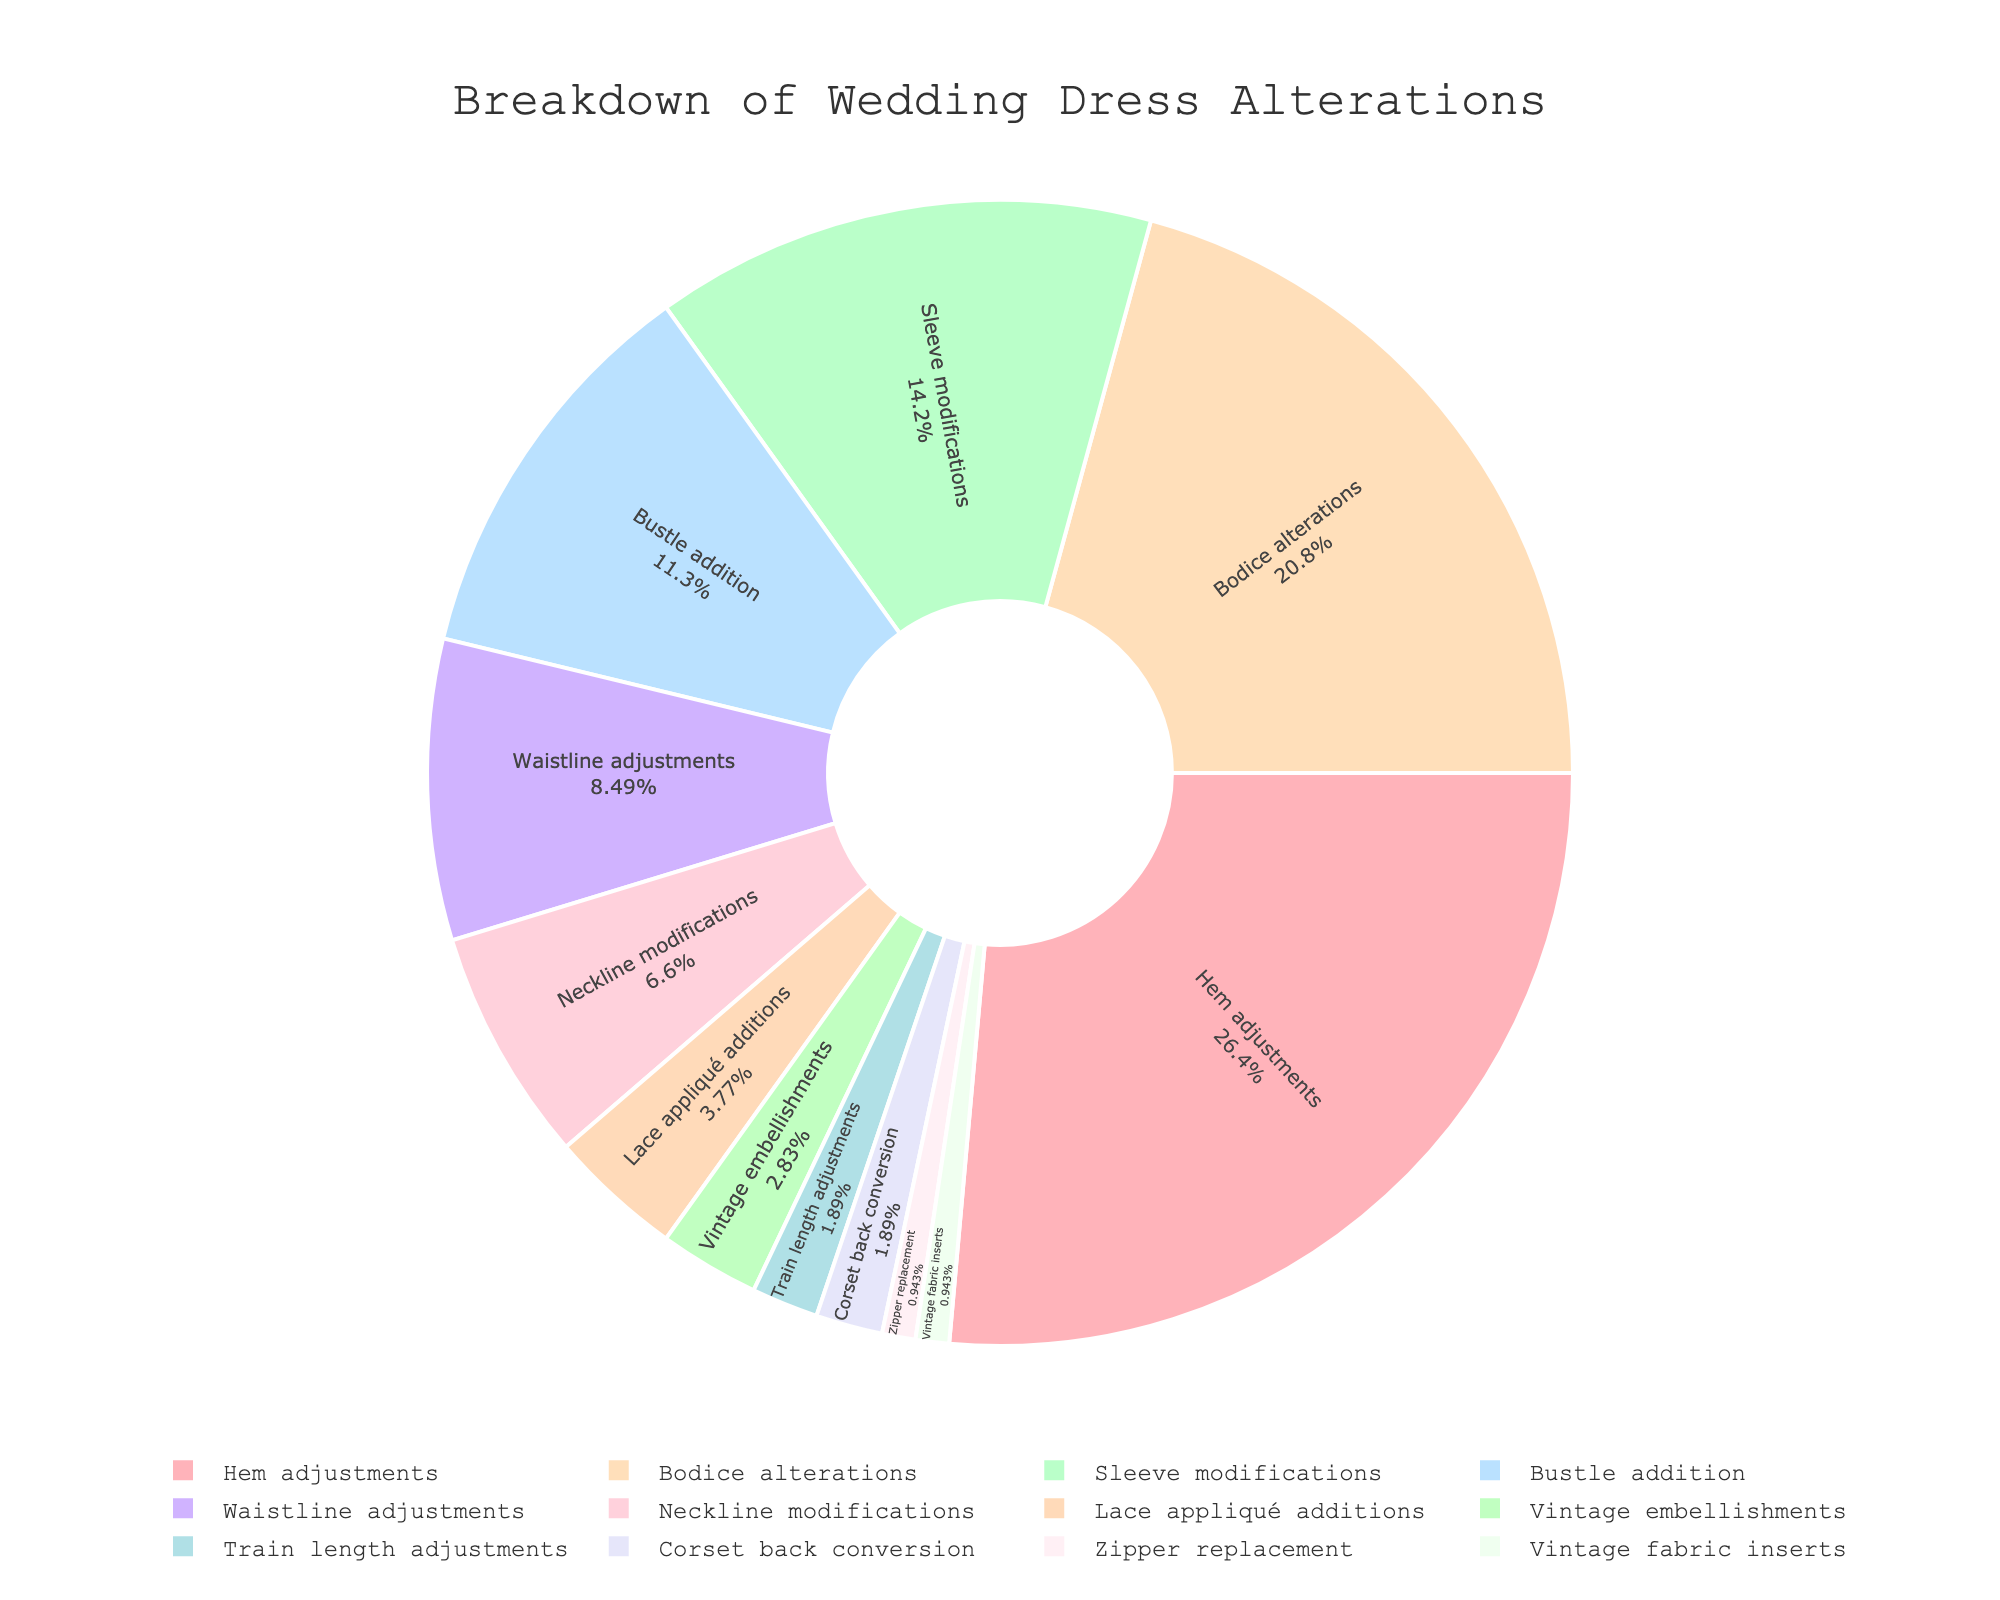Which alteration category has the highest percentage? Identify the segment with the largest size and corresponding label. The segment for 'Hem adjustments' is the largest with 28%.
Answer: Hem adjustments Which two categories have the smallest percentage? Look for the two smallest segments in the pie chart. The smallest segments are 'Zipper replacement' and 'Vintage fabric inserts', each with 1%.
Answer: Zipper replacement and Vintage fabric inserts What is the combined percentage of Bustle addition and Sleeve modifications? Add the percentages of 'Bustle addition' which is 12% and 'Sleeve modifications' which is 15%. 12 + 15 equals 27%.
Answer: 27% Is the percentage for Waistline adjustments greater than Neckline modifications? Compare the sizes of the segments for 'Waistline adjustments' (9%) and 'Neckline modifications' (7%). Since 9% is greater than 7%, the answer is yes.
Answer: Yes How many categories have a percentage of 5% or less? Count the segments with 5% or less. These are 'Lace appliqué additions' (4%), 'Vintage embellishments' (3%), 'Train length adjustments' (2%), 'Corset back conversion' (2%), 'Zipper replacement' (1%), and 'Vintage fabric inserts' (1%), totaling 6 categories.
Answer: 6 What is the difference in percentage between Hem adjustments and Bodice alterations? Subtract the percentage of 'Bodice alterations' (22%) from 'Hem adjustments' (28%). 28 - 22 equals 6%.
Answer: 6% What is the percentage of the largest category compared to the smallest category? Compare the largest segment 'Hem adjustments' (28%) with the smallest segments 'Zipper replacement' and 'Vintage fabric inserts' (each 1%). 28 / 1 equals 28 times.
Answer: 28 times 